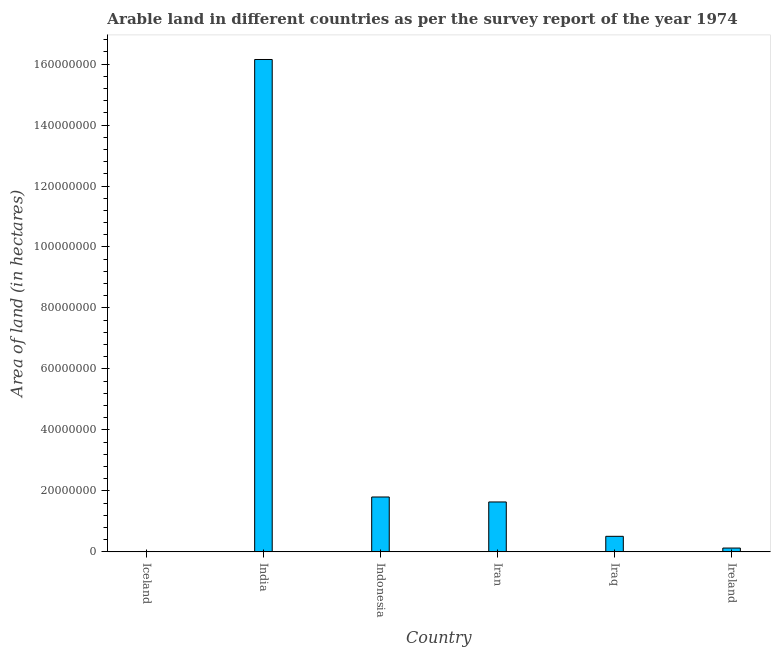What is the title of the graph?
Your answer should be compact. Arable land in different countries as per the survey report of the year 1974. What is the label or title of the Y-axis?
Offer a very short reply. Area of land (in hectares). What is the area of land in Ireland?
Offer a terse response. 1.25e+06. Across all countries, what is the maximum area of land?
Provide a succinct answer. 1.62e+08. Across all countries, what is the minimum area of land?
Make the answer very short. 1.25e+05. What is the sum of the area of land?
Your answer should be very brief. 2.02e+08. What is the difference between the area of land in India and Ireland?
Keep it short and to the point. 1.60e+08. What is the average area of land per country?
Provide a succinct answer. 3.37e+07. What is the median area of land?
Keep it short and to the point. 1.07e+07. What is the ratio of the area of land in Iraq to that in Ireland?
Provide a short and direct response. 4.07. Is the difference between the area of land in Iceland and Iran greater than the difference between any two countries?
Keep it short and to the point. No. What is the difference between the highest and the second highest area of land?
Your response must be concise. 1.44e+08. What is the difference between the highest and the lowest area of land?
Give a very brief answer. 1.61e+08. Are all the bars in the graph horizontal?
Your answer should be compact. No. What is the difference between two consecutive major ticks on the Y-axis?
Your answer should be compact. 2.00e+07. Are the values on the major ticks of Y-axis written in scientific E-notation?
Provide a succinct answer. No. What is the Area of land (in hectares) in Iceland?
Your answer should be very brief. 1.25e+05. What is the Area of land (in hectares) in India?
Offer a terse response. 1.62e+08. What is the Area of land (in hectares) in Indonesia?
Your answer should be compact. 1.80e+07. What is the Area of land (in hectares) of Iran?
Make the answer very short. 1.64e+07. What is the Area of land (in hectares) of Iraq?
Offer a terse response. 5.10e+06. What is the Area of land (in hectares) of Ireland?
Ensure brevity in your answer.  1.25e+06. What is the difference between the Area of land (in hectares) in Iceland and India?
Your response must be concise. -1.61e+08. What is the difference between the Area of land (in hectares) in Iceland and Indonesia?
Your response must be concise. -1.79e+07. What is the difference between the Area of land (in hectares) in Iceland and Iran?
Your answer should be very brief. -1.62e+07. What is the difference between the Area of land (in hectares) in Iceland and Iraq?
Offer a terse response. -4.98e+06. What is the difference between the Area of land (in hectares) in Iceland and Ireland?
Ensure brevity in your answer.  -1.13e+06. What is the difference between the Area of land (in hectares) in India and Indonesia?
Ensure brevity in your answer.  1.44e+08. What is the difference between the Area of land (in hectares) in India and Iran?
Offer a terse response. 1.45e+08. What is the difference between the Area of land (in hectares) in India and Iraq?
Your response must be concise. 1.56e+08. What is the difference between the Area of land (in hectares) in India and Ireland?
Provide a succinct answer. 1.60e+08. What is the difference between the Area of land (in hectares) in Indonesia and Iran?
Your response must be concise. 1.63e+06. What is the difference between the Area of land (in hectares) in Indonesia and Iraq?
Make the answer very short. 1.29e+07. What is the difference between the Area of land (in hectares) in Indonesia and Ireland?
Offer a very short reply. 1.67e+07. What is the difference between the Area of land (in hectares) in Iran and Iraq?
Make the answer very short. 1.13e+07. What is the difference between the Area of land (in hectares) in Iran and Ireland?
Make the answer very short. 1.51e+07. What is the difference between the Area of land (in hectares) in Iraq and Ireland?
Provide a succinct answer. 3.85e+06. What is the ratio of the Area of land (in hectares) in Iceland to that in Indonesia?
Provide a short and direct response. 0.01. What is the ratio of the Area of land (in hectares) in Iceland to that in Iran?
Offer a very short reply. 0.01. What is the ratio of the Area of land (in hectares) in Iceland to that in Iraq?
Provide a short and direct response. 0.03. What is the ratio of the Area of land (in hectares) in India to that in Indonesia?
Your response must be concise. 8.97. What is the ratio of the Area of land (in hectares) in India to that in Iran?
Provide a short and direct response. 9.87. What is the ratio of the Area of land (in hectares) in India to that in Iraq?
Your response must be concise. 31.67. What is the ratio of the Area of land (in hectares) in India to that in Ireland?
Offer a terse response. 128.89. What is the ratio of the Area of land (in hectares) in Indonesia to that in Iran?
Keep it short and to the point. 1.1. What is the ratio of the Area of land (in hectares) in Indonesia to that in Iraq?
Provide a succinct answer. 3.53. What is the ratio of the Area of land (in hectares) in Indonesia to that in Ireland?
Offer a very short reply. 14.37. What is the ratio of the Area of land (in hectares) in Iran to that in Iraq?
Your answer should be very brief. 3.21. What is the ratio of the Area of land (in hectares) in Iran to that in Ireland?
Offer a terse response. 13.06. What is the ratio of the Area of land (in hectares) in Iraq to that in Ireland?
Your response must be concise. 4.07. 